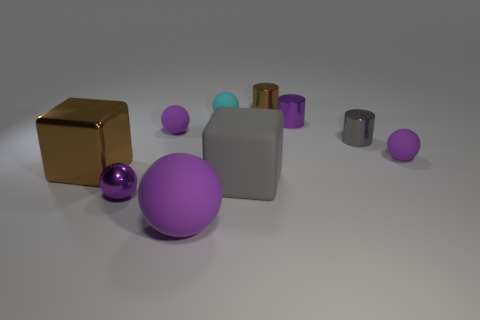How many purple balls must be subtracted to get 2 purple balls? 2 Subtract all tiny balls. How many balls are left? 1 Subtract all cylinders. How many objects are left? 7 Subtract all purple cylinders. How many cylinders are left? 2 Subtract 1 cylinders. How many cylinders are left? 2 Subtract all cyan cubes. Subtract all blue cylinders. How many cubes are left? 2 Subtract all gray cylinders. How many brown blocks are left? 1 Subtract all small gray cylinders. Subtract all metal blocks. How many objects are left? 8 Add 2 small cyan objects. How many small cyan objects are left? 3 Add 2 gray metal things. How many gray metal things exist? 3 